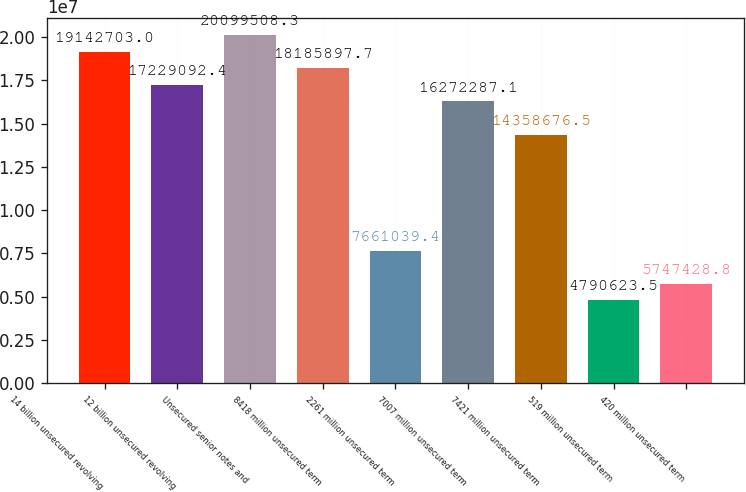Convert chart to OTSL. <chart><loc_0><loc_0><loc_500><loc_500><bar_chart><fcel>14 billion unsecured revolving<fcel>12 billion unsecured revolving<fcel>Unsecured senior notes and<fcel>8418 million unsecured term<fcel>2261 million unsecured term<fcel>7007 million unsecured term<fcel>7421 million unsecured term<fcel>519 million unsecured term<fcel>420 million unsecured term<nl><fcel>1.91427e+07<fcel>1.72291e+07<fcel>2.00995e+07<fcel>1.81859e+07<fcel>7.66104e+06<fcel>1.62723e+07<fcel>1.43587e+07<fcel>4.79062e+06<fcel>5.74743e+06<nl></chart> 